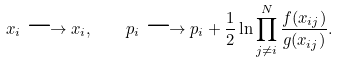<formula> <loc_0><loc_0><loc_500><loc_500>x _ { i } \longrightarrow x _ { i } , \quad p _ { i } \longrightarrow p _ { i } + \frac { 1 } { 2 } \ln \prod _ { j \neq i } ^ { N } \frac { f ( x _ { i j } ) } { g ( x _ { i j } ) } .</formula> 